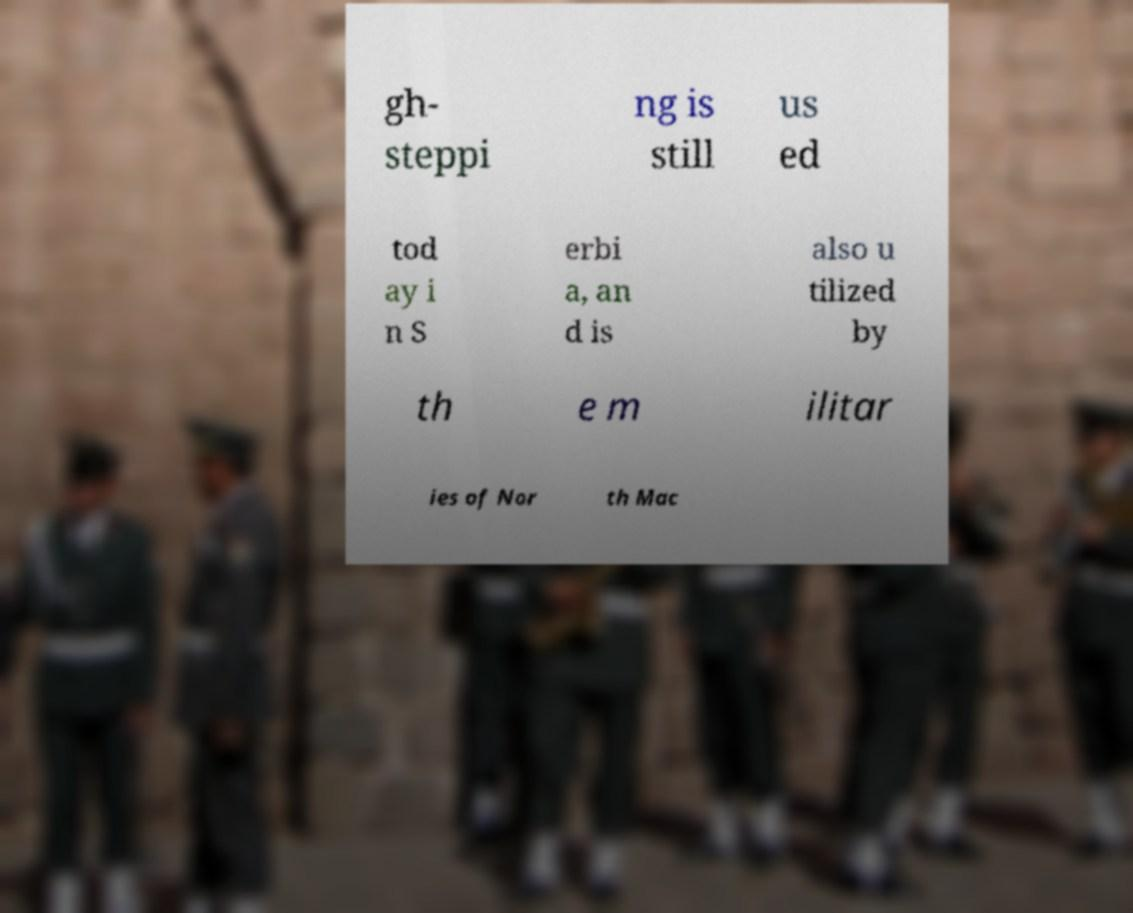Please identify and transcribe the text found in this image. gh- steppi ng is still us ed tod ay i n S erbi a, an d is also u tilized by th e m ilitar ies of Nor th Mac 